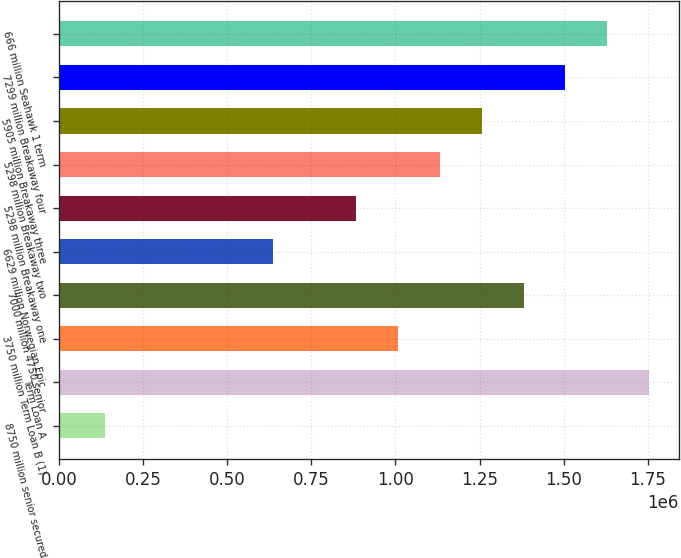Convert chart. <chart><loc_0><loc_0><loc_500><loc_500><bar_chart><fcel>8750 million senior secured<fcel>Term Loan A<fcel>3750 million Term Loan B (1)<fcel>7000 million 4750 senior<fcel>6629 million Norwegian Epic<fcel>5298 million Breakaway one<fcel>5298 million Breakaway two<fcel>5905 million Breakaway three<fcel>7299 million Breakaway four<fcel>666 million Seahawk 1 term<nl><fcel>138087<fcel>1.75309e+06<fcel>1.0077e+06<fcel>1.3804e+06<fcel>635012<fcel>883474<fcel>1.13194e+06<fcel>1.25617e+06<fcel>1.50463e+06<fcel>1.62886e+06<nl></chart> 